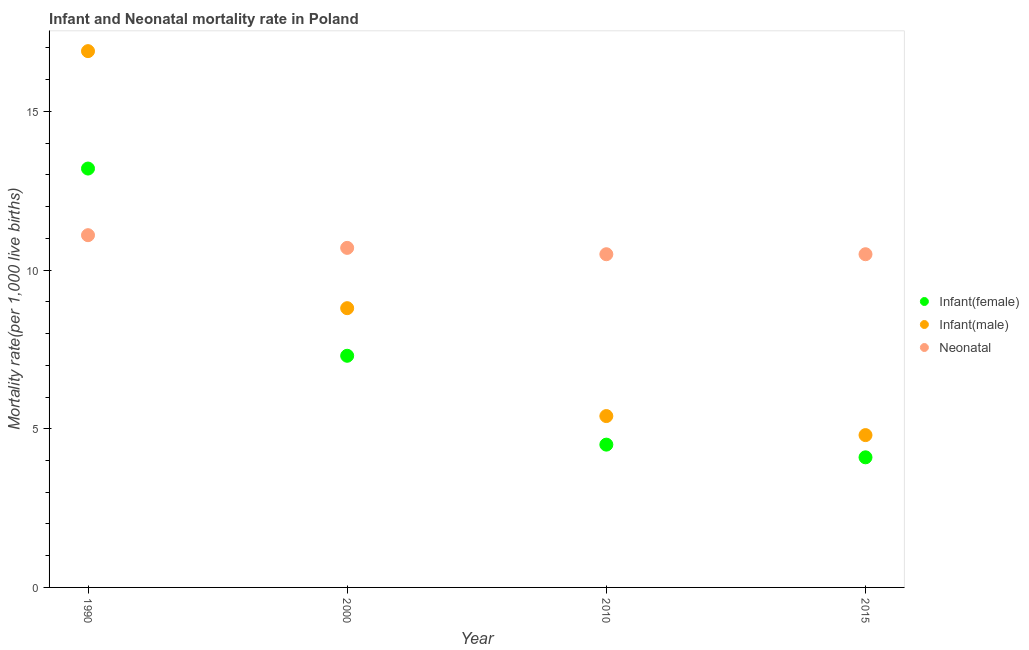How many different coloured dotlines are there?
Offer a terse response. 3. Is the number of dotlines equal to the number of legend labels?
Provide a short and direct response. Yes. What is the infant mortality rate(male) in 2000?
Give a very brief answer. 8.8. In which year was the infant mortality rate(male) minimum?
Make the answer very short. 2015. What is the total infant mortality rate(male) in the graph?
Your response must be concise. 35.9. What is the difference between the infant mortality rate(male) in 2010 and that in 2015?
Offer a terse response. 0.6. In the year 1990, what is the difference between the infant mortality rate(female) and neonatal mortality rate?
Ensure brevity in your answer.  2.1. What is the ratio of the neonatal mortality rate in 1990 to that in 2000?
Offer a very short reply. 1.04. What is the difference between the highest and the second highest infant mortality rate(male)?
Ensure brevity in your answer.  8.1. What is the difference between the highest and the lowest neonatal mortality rate?
Your response must be concise. 0.6. In how many years, is the infant mortality rate(male) greater than the average infant mortality rate(male) taken over all years?
Your answer should be very brief. 1. How many dotlines are there?
Give a very brief answer. 3. Are the values on the major ticks of Y-axis written in scientific E-notation?
Keep it short and to the point. No. Does the graph contain any zero values?
Offer a terse response. No. Does the graph contain grids?
Your answer should be very brief. No. How are the legend labels stacked?
Offer a terse response. Vertical. What is the title of the graph?
Your answer should be very brief. Infant and Neonatal mortality rate in Poland. Does "Coal" appear as one of the legend labels in the graph?
Give a very brief answer. No. What is the label or title of the X-axis?
Your response must be concise. Year. What is the label or title of the Y-axis?
Give a very brief answer. Mortality rate(per 1,0 live births). What is the Mortality rate(per 1,000 live births) of Infant(male) in 1990?
Provide a succinct answer. 16.9. What is the Mortality rate(per 1,000 live births) in Infant(male) in 2000?
Provide a succinct answer. 8.8. What is the Mortality rate(per 1,000 live births) of Neonatal  in 2000?
Your answer should be compact. 10.7. What is the Mortality rate(per 1,000 live births) of Infant(female) in 2010?
Give a very brief answer. 4.5. What is the Mortality rate(per 1,000 live births) of Neonatal  in 2015?
Your answer should be very brief. 10.5. Across all years, what is the maximum Mortality rate(per 1,000 live births) of Infant(female)?
Your answer should be compact. 13.2. Across all years, what is the maximum Mortality rate(per 1,000 live births) in Infant(male)?
Your answer should be compact. 16.9. Across all years, what is the maximum Mortality rate(per 1,000 live births) of Neonatal ?
Provide a succinct answer. 11.1. Across all years, what is the minimum Mortality rate(per 1,000 live births) in Infant(female)?
Keep it short and to the point. 4.1. What is the total Mortality rate(per 1,000 live births) in Infant(female) in the graph?
Offer a terse response. 29.1. What is the total Mortality rate(per 1,000 live births) in Infant(male) in the graph?
Make the answer very short. 35.9. What is the total Mortality rate(per 1,000 live births) of Neonatal  in the graph?
Give a very brief answer. 42.8. What is the difference between the Mortality rate(per 1,000 live births) in Infant(male) in 1990 and that in 2000?
Your answer should be compact. 8.1. What is the difference between the Mortality rate(per 1,000 live births) of Neonatal  in 1990 and that in 2000?
Your response must be concise. 0.4. What is the difference between the Mortality rate(per 1,000 live births) of Infant(female) in 1990 and that in 2010?
Offer a terse response. 8.7. What is the difference between the Mortality rate(per 1,000 live births) in Infant(male) in 1990 and that in 2010?
Offer a terse response. 11.5. What is the difference between the Mortality rate(per 1,000 live births) of Neonatal  in 1990 and that in 2010?
Provide a short and direct response. 0.6. What is the difference between the Mortality rate(per 1,000 live births) of Neonatal  in 1990 and that in 2015?
Provide a short and direct response. 0.6. What is the difference between the Mortality rate(per 1,000 live births) in Infant(female) in 2000 and that in 2010?
Give a very brief answer. 2.8. What is the difference between the Mortality rate(per 1,000 live births) in Infant(male) in 2000 and that in 2010?
Offer a very short reply. 3.4. What is the difference between the Mortality rate(per 1,000 live births) in Neonatal  in 2000 and that in 2015?
Your answer should be compact. 0.2. What is the difference between the Mortality rate(per 1,000 live births) of Infant(female) in 2010 and that in 2015?
Make the answer very short. 0.4. What is the difference between the Mortality rate(per 1,000 live births) in Infant(male) in 1990 and the Mortality rate(per 1,000 live births) in Neonatal  in 2000?
Make the answer very short. 6.2. What is the difference between the Mortality rate(per 1,000 live births) in Infant(female) in 1990 and the Mortality rate(per 1,000 live births) in Infant(male) in 2010?
Keep it short and to the point. 7.8. What is the difference between the Mortality rate(per 1,000 live births) of Infant(female) in 1990 and the Mortality rate(per 1,000 live births) of Neonatal  in 2010?
Your answer should be very brief. 2.7. What is the difference between the Mortality rate(per 1,000 live births) in Infant(male) in 1990 and the Mortality rate(per 1,000 live births) in Neonatal  in 2010?
Provide a short and direct response. 6.4. What is the difference between the Mortality rate(per 1,000 live births) in Infant(female) in 1990 and the Mortality rate(per 1,000 live births) in Infant(male) in 2015?
Ensure brevity in your answer.  8.4. What is the difference between the Mortality rate(per 1,000 live births) of Infant(female) in 1990 and the Mortality rate(per 1,000 live births) of Neonatal  in 2015?
Your answer should be compact. 2.7. What is the difference between the Mortality rate(per 1,000 live births) of Infant(female) in 2000 and the Mortality rate(per 1,000 live births) of Infant(male) in 2010?
Offer a very short reply. 1.9. What is the difference between the Mortality rate(per 1,000 live births) in Infant(female) in 2000 and the Mortality rate(per 1,000 live births) in Neonatal  in 2015?
Make the answer very short. -3.2. What is the difference between the Mortality rate(per 1,000 live births) of Infant(male) in 2000 and the Mortality rate(per 1,000 live births) of Neonatal  in 2015?
Give a very brief answer. -1.7. What is the difference between the Mortality rate(per 1,000 live births) in Infant(female) in 2010 and the Mortality rate(per 1,000 live births) in Neonatal  in 2015?
Provide a short and direct response. -6. What is the difference between the Mortality rate(per 1,000 live births) in Infant(male) in 2010 and the Mortality rate(per 1,000 live births) in Neonatal  in 2015?
Your response must be concise. -5.1. What is the average Mortality rate(per 1,000 live births) of Infant(female) per year?
Provide a succinct answer. 7.28. What is the average Mortality rate(per 1,000 live births) in Infant(male) per year?
Your response must be concise. 8.97. What is the average Mortality rate(per 1,000 live births) in Neonatal  per year?
Your response must be concise. 10.7. In the year 1990, what is the difference between the Mortality rate(per 1,000 live births) in Infant(female) and Mortality rate(per 1,000 live births) in Infant(male)?
Keep it short and to the point. -3.7. In the year 1990, what is the difference between the Mortality rate(per 1,000 live births) of Infant(female) and Mortality rate(per 1,000 live births) of Neonatal ?
Offer a terse response. 2.1. In the year 2000, what is the difference between the Mortality rate(per 1,000 live births) of Infant(female) and Mortality rate(per 1,000 live births) of Infant(male)?
Ensure brevity in your answer.  -1.5. In the year 2000, what is the difference between the Mortality rate(per 1,000 live births) of Infant(female) and Mortality rate(per 1,000 live births) of Neonatal ?
Provide a succinct answer. -3.4. In the year 2000, what is the difference between the Mortality rate(per 1,000 live births) of Infant(male) and Mortality rate(per 1,000 live births) of Neonatal ?
Provide a succinct answer. -1.9. In the year 2015, what is the difference between the Mortality rate(per 1,000 live births) in Infant(female) and Mortality rate(per 1,000 live births) in Infant(male)?
Your response must be concise. -0.7. What is the ratio of the Mortality rate(per 1,000 live births) in Infant(female) in 1990 to that in 2000?
Make the answer very short. 1.81. What is the ratio of the Mortality rate(per 1,000 live births) in Infant(male) in 1990 to that in 2000?
Offer a terse response. 1.92. What is the ratio of the Mortality rate(per 1,000 live births) in Neonatal  in 1990 to that in 2000?
Keep it short and to the point. 1.04. What is the ratio of the Mortality rate(per 1,000 live births) of Infant(female) in 1990 to that in 2010?
Provide a succinct answer. 2.93. What is the ratio of the Mortality rate(per 1,000 live births) in Infant(male) in 1990 to that in 2010?
Your answer should be very brief. 3.13. What is the ratio of the Mortality rate(per 1,000 live births) of Neonatal  in 1990 to that in 2010?
Provide a succinct answer. 1.06. What is the ratio of the Mortality rate(per 1,000 live births) of Infant(female) in 1990 to that in 2015?
Ensure brevity in your answer.  3.22. What is the ratio of the Mortality rate(per 1,000 live births) of Infant(male) in 1990 to that in 2015?
Make the answer very short. 3.52. What is the ratio of the Mortality rate(per 1,000 live births) of Neonatal  in 1990 to that in 2015?
Your response must be concise. 1.06. What is the ratio of the Mortality rate(per 1,000 live births) in Infant(female) in 2000 to that in 2010?
Your answer should be very brief. 1.62. What is the ratio of the Mortality rate(per 1,000 live births) in Infant(male) in 2000 to that in 2010?
Ensure brevity in your answer.  1.63. What is the ratio of the Mortality rate(per 1,000 live births) of Infant(female) in 2000 to that in 2015?
Keep it short and to the point. 1.78. What is the ratio of the Mortality rate(per 1,000 live births) of Infant(male) in 2000 to that in 2015?
Make the answer very short. 1.83. What is the ratio of the Mortality rate(per 1,000 live births) in Infant(female) in 2010 to that in 2015?
Make the answer very short. 1.1. What is the ratio of the Mortality rate(per 1,000 live births) of Infant(male) in 2010 to that in 2015?
Provide a short and direct response. 1.12. What is the difference between the highest and the second highest Mortality rate(per 1,000 live births) in Infant(female)?
Offer a very short reply. 5.9. What is the difference between the highest and the second highest Mortality rate(per 1,000 live births) of Infant(male)?
Keep it short and to the point. 8.1. What is the difference between the highest and the lowest Mortality rate(per 1,000 live births) of Infant(male)?
Give a very brief answer. 12.1. What is the difference between the highest and the lowest Mortality rate(per 1,000 live births) in Neonatal ?
Make the answer very short. 0.6. 